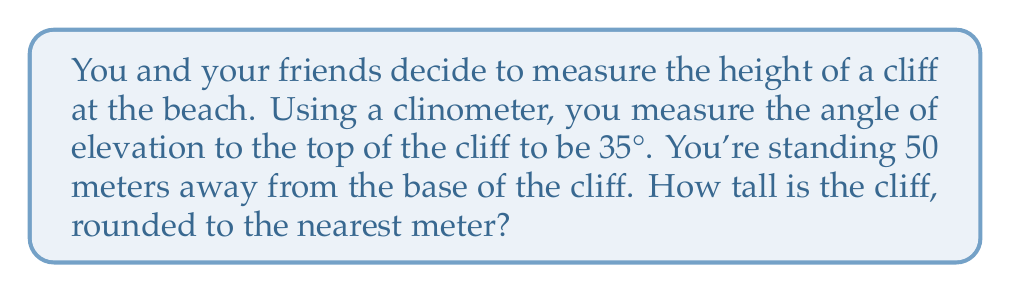Solve this math problem. Let's approach this step-by-step:

1) First, let's visualize the problem:

[asy]
import geometry;

size(200);
pair A = (0,0), B = (5,0), C = (5,3.5);
draw(A--B--C--A);
label("50 m", (2.5,0), S);
label("h", (5,1.75), E);
label("35°", (0,0), NW);
draw(arc(A,0.5,0,35),Arrow);
[/asy]

2) We can see that this forms a right-angled triangle. We know:
   - The adjacent side (distance from you to the cliff) = 50 meters
   - The angle of elevation = 35°
   - We need to find the opposite side (height of the cliff)

3) In this case, we need to use the tangent ratio:

   $\tan \theta = \frac{\text{opposite}}{\text{adjacent}}$

4) Let's plug in our known values:

   $\tan 35° = \frac{h}{50}$

   Where $h$ is the height of the cliff.

5) To solve for $h$, we multiply both sides by 50:

   $50 \tan 35° = h$

6) Now we can calculate:
   
   $h = 50 \times \tan 35°$
   
   $h = 50 \times 0.7002075$
   
   $h = 35.010375$ meters

7) Rounding to the nearest meter:

   $h \approx 35$ meters
Answer: 35 meters 